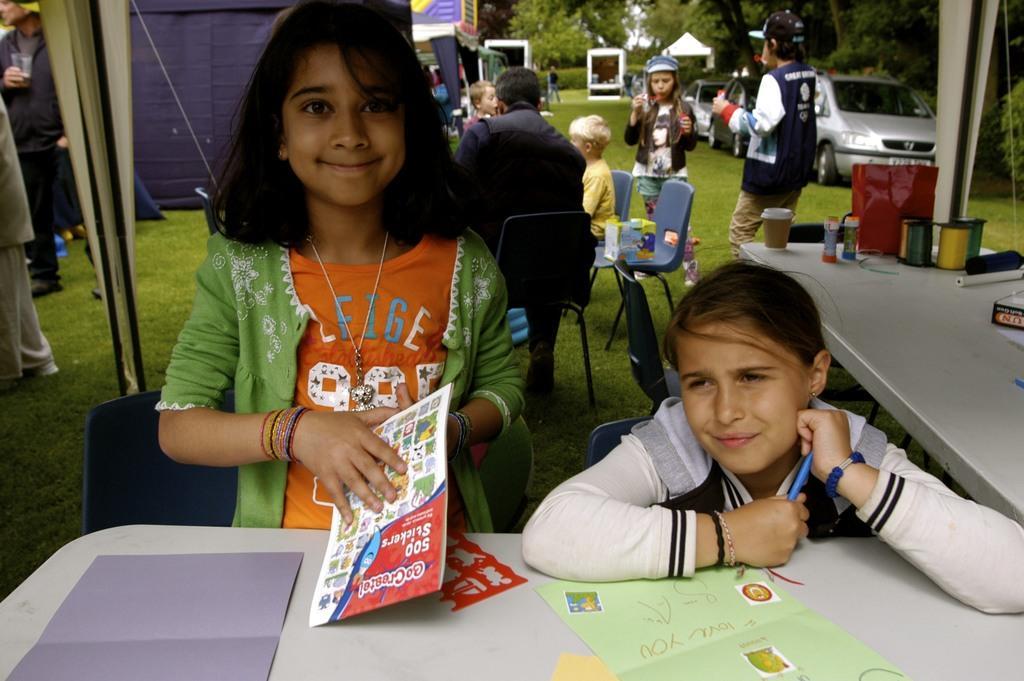Can you describe this image briefly? In this picture I can see few people are sitting in the chairs and few are standing and I can see papers on the table and a girl holding a paper in her hand. I can see few bottles, cups, a carry bag on the another table and on the left side I can see a man standing and holding a glass in his hand. I can see cars, tents and few vehicles in the back and I can see trees and grass on the ground. 